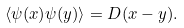<formula> <loc_0><loc_0><loc_500><loc_500>\langle \psi ( x ) \psi ( y ) \rangle = D ( x - y ) .</formula> 